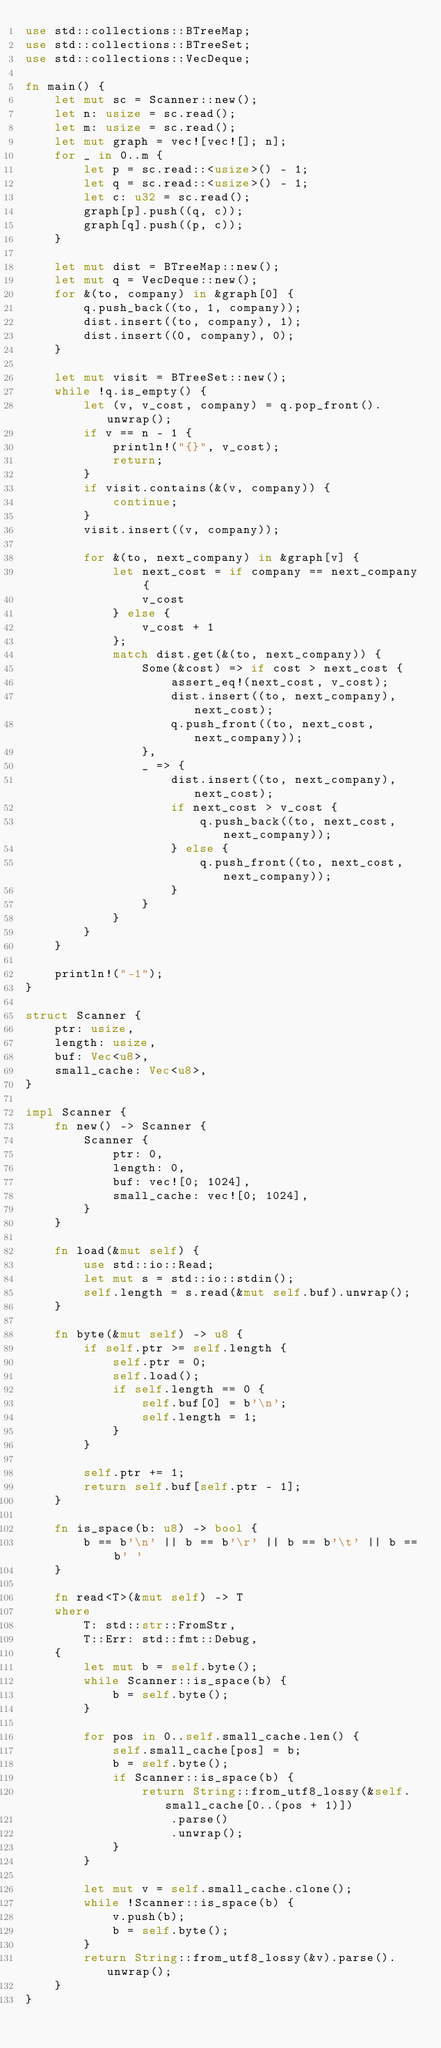<code> <loc_0><loc_0><loc_500><loc_500><_Rust_>use std::collections::BTreeMap;
use std::collections::BTreeSet;
use std::collections::VecDeque;

fn main() {
    let mut sc = Scanner::new();
    let n: usize = sc.read();
    let m: usize = sc.read();
    let mut graph = vec![vec![]; n];
    for _ in 0..m {
        let p = sc.read::<usize>() - 1;
        let q = sc.read::<usize>() - 1;
        let c: u32 = sc.read();
        graph[p].push((q, c));
        graph[q].push((p, c));
    }

    let mut dist = BTreeMap::new();
    let mut q = VecDeque::new();
    for &(to, company) in &graph[0] {
        q.push_back((to, 1, company));
        dist.insert((to, company), 1);
        dist.insert((0, company), 0);
    }

    let mut visit = BTreeSet::new();
    while !q.is_empty() {
        let (v, v_cost, company) = q.pop_front().unwrap();
        if v == n - 1 {
            println!("{}", v_cost);
            return;
        }
        if visit.contains(&(v, company)) {
            continue;
        }
        visit.insert((v, company));

        for &(to, next_company) in &graph[v] {
            let next_cost = if company == next_company {
                v_cost
            } else {
                v_cost + 1
            };
            match dist.get(&(to, next_company)) {
                Some(&cost) => if cost > next_cost {
                    assert_eq!(next_cost, v_cost);
                    dist.insert((to, next_company), next_cost);
                    q.push_front((to, next_cost, next_company));
                },
                _ => {
                    dist.insert((to, next_company), next_cost);
                    if next_cost > v_cost {
                        q.push_back((to, next_cost, next_company));
                    } else {
                        q.push_front((to, next_cost, next_company));
                    }
                }
            }
        }
    }

    println!("-1");
}

struct Scanner {
    ptr: usize,
    length: usize,
    buf: Vec<u8>,
    small_cache: Vec<u8>,
}

impl Scanner {
    fn new() -> Scanner {
        Scanner {
            ptr: 0,
            length: 0,
            buf: vec![0; 1024],
            small_cache: vec![0; 1024],
        }
    }

    fn load(&mut self) {
        use std::io::Read;
        let mut s = std::io::stdin();
        self.length = s.read(&mut self.buf).unwrap();
    }

    fn byte(&mut self) -> u8 {
        if self.ptr >= self.length {
            self.ptr = 0;
            self.load();
            if self.length == 0 {
                self.buf[0] = b'\n';
                self.length = 1;
            }
        }

        self.ptr += 1;
        return self.buf[self.ptr - 1];
    }

    fn is_space(b: u8) -> bool {
        b == b'\n' || b == b'\r' || b == b'\t' || b == b' '
    }

    fn read<T>(&mut self) -> T
    where
        T: std::str::FromStr,
        T::Err: std::fmt::Debug,
    {
        let mut b = self.byte();
        while Scanner::is_space(b) {
            b = self.byte();
        }

        for pos in 0..self.small_cache.len() {
            self.small_cache[pos] = b;
            b = self.byte();
            if Scanner::is_space(b) {
                return String::from_utf8_lossy(&self.small_cache[0..(pos + 1)])
                    .parse()
                    .unwrap();
            }
        }

        let mut v = self.small_cache.clone();
        while !Scanner::is_space(b) {
            v.push(b);
            b = self.byte();
        }
        return String::from_utf8_lossy(&v).parse().unwrap();
    }
}
</code> 